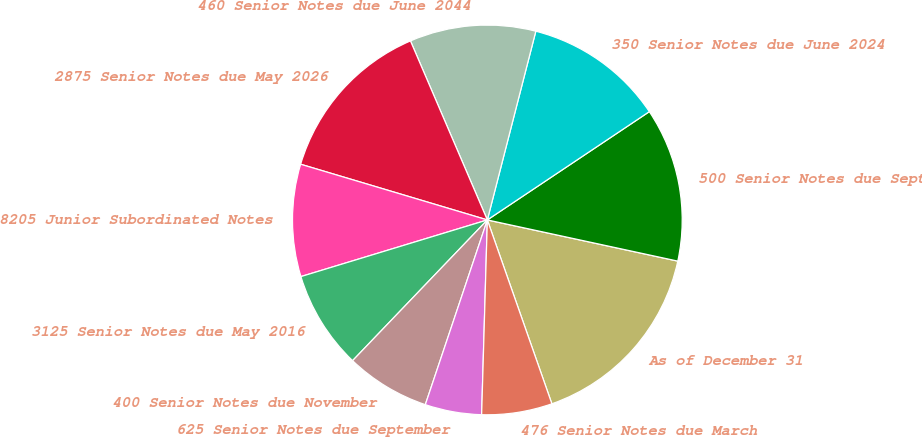Convert chart to OTSL. <chart><loc_0><loc_0><loc_500><loc_500><pie_chart><fcel>As of December 31<fcel>500 Senior Notes due September<fcel>350 Senior Notes due June 2024<fcel>460 Senior Notes due June 2044<fcel>2875 Senior Notes due May 2026<fcel>8205 Junior Subordinated Notes<fcel>3125 Senior Notes due May 2016<fcel>400 Senior Notes due November<fcel>625 Senior Notes due September<fcel>476 Senior Notes due March<nl><fcel>16.24%<fcel>12.77%<fcel>11.62%<fcel>10.46%<fcel>13.93%<fcel>9.31%<fcel>8.15%<fcel>7.0%<fcel>4.69%<fcel>5.84%<nl></chart> 